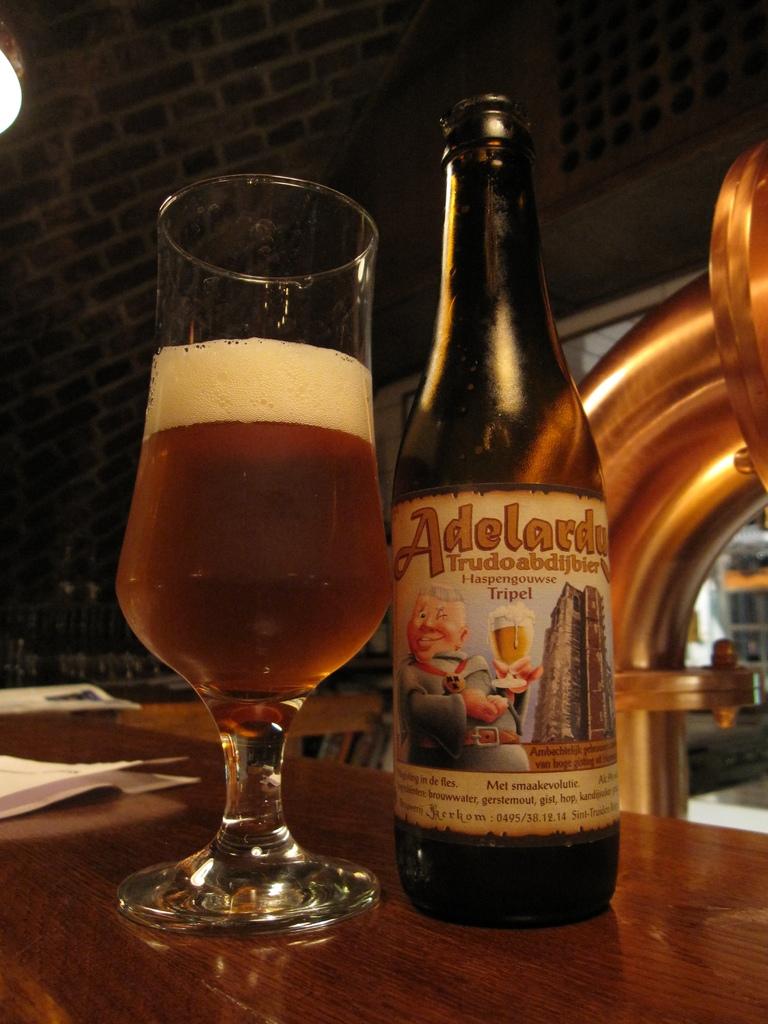Is this written in english?
Offer a very short reply. No. 